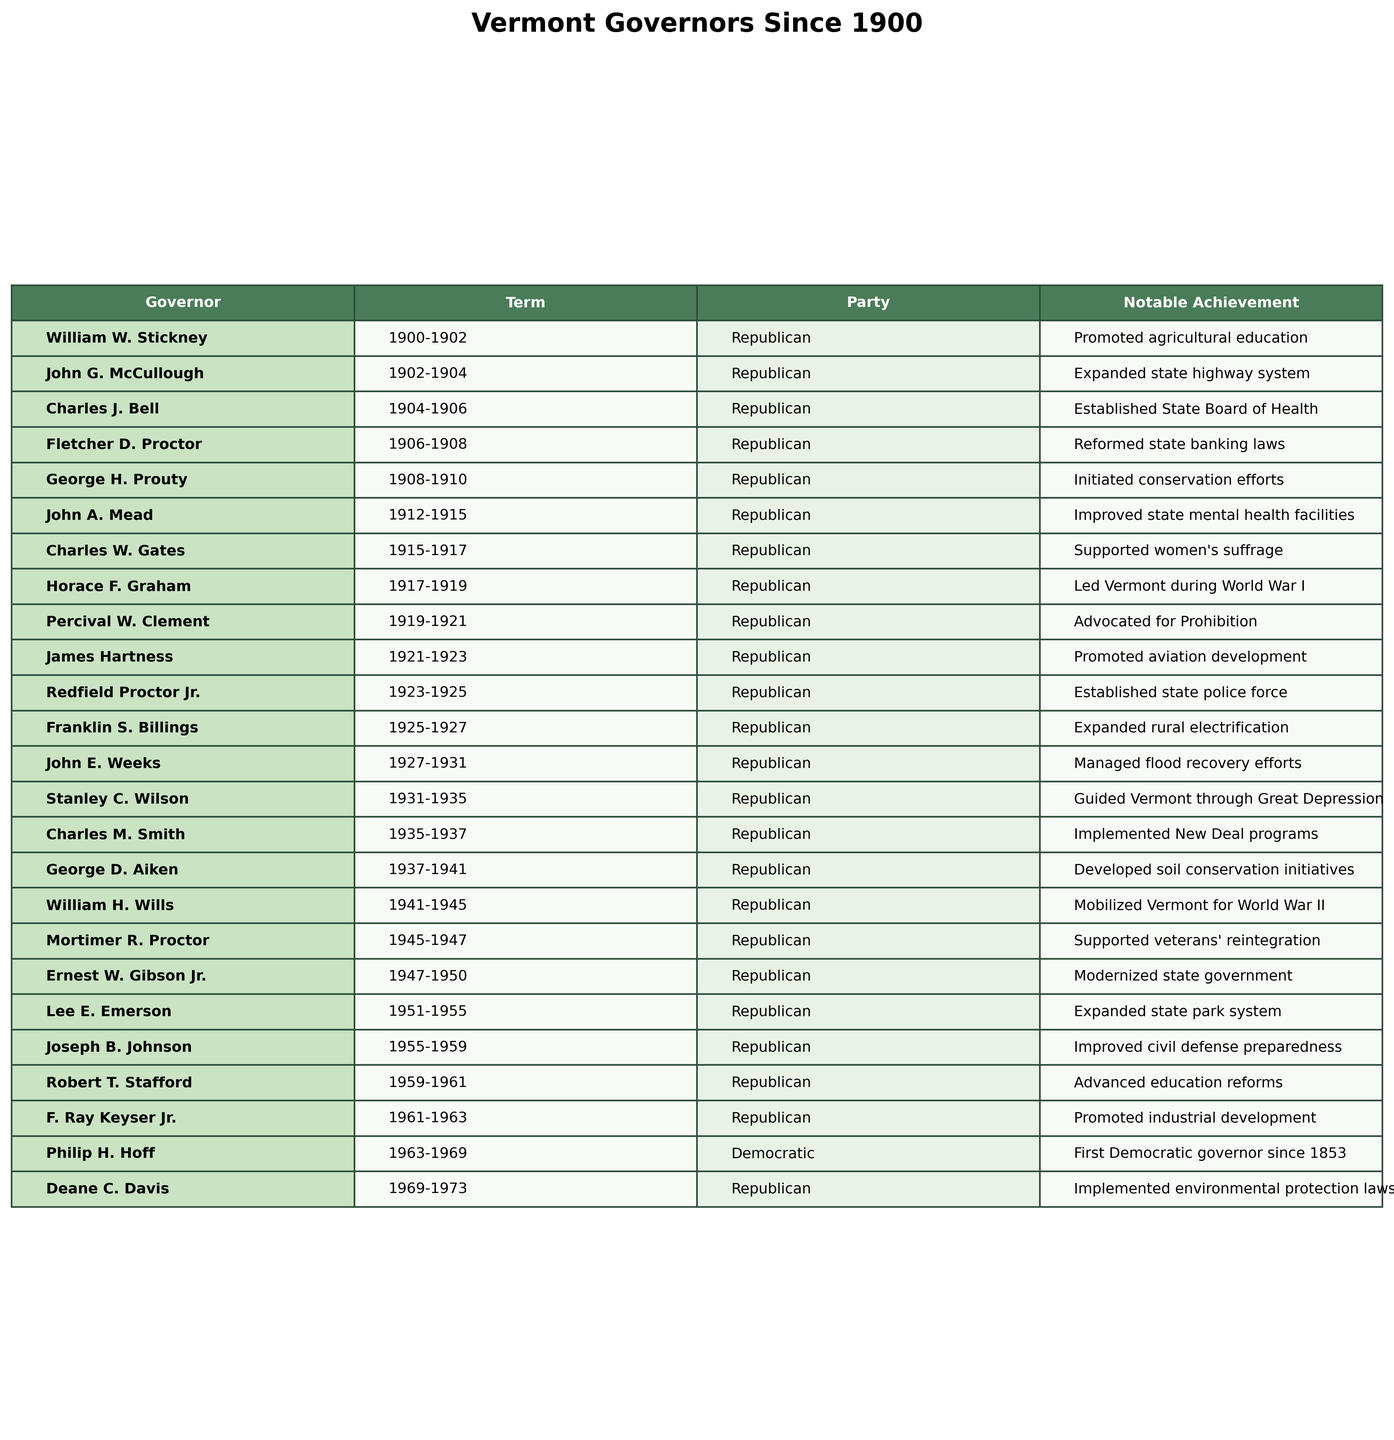What were the years of William W. Stickney's term? The table shows that William W. Stickney served as governor from 1900 to 1902.
Answer: 1900-1902 Which governor had the longest term in office? By checking the "Start Year" and "End Year" columns, we see that Stanley C. Wilson served from 1931 to 1935, totaling 4 years, which is the longest duration among the listed governors.
Answer: Stanley C. Wilson How many governors served from the Republican Party? All governors listed from 1900 to 1973 except for Philip H. Hoff (1963-1969) were from the Republican Party. Counting these, there are 22 Republican governors.
Answer: 22 Did any governor serve during World War II? William H. Wills served from 1941 to 1945, which overlaps with the World War II timeline. Hence, the answer is yes.
Answer: Yes What notable achievement is attributed to George D. Aiken? Referring to the table, George D. Aiken's notable achievement was developing soil conservation initiatives.
Answer: Developed soil conservation initiatives Calculate the total number of years served by all governors listed in the table. Adding together all the years served (2 + 2 + 2 + 2 + 2 + 3 + 2 + 2 + 2 + 2 + 2 + 4 + 4 + 4 + 4 + 2 + 3 + 2 + 2 + 6 + 4 = 60), the total is 60 years.
Answer: 60 Was there any governor who directly contributed to women's suffrage? The table lists Charles W. Gates, who was noted for supporting women's suffrage. Hence, the answer is yes.
Answer: Yes Identify the governor directly associated with the establishment of the state police force. According to the table, Redfield Proctor Jr. is the governor who established the state police force between 1923 and 1925.
Answer: Redfield Proctor Jr Which party did Philip H. Hoff belong to? The table explicitly categorizes Philip H. Hoff under the Democratic Party, signifying his political affiliation.
Answer: Democratic Party What is the notable achievement of Ernest W. Gibson Jr.? The table states that Ernest W. Gibson Jr. modernized state government, which is his notable achievement.
Answer: Modernized state government Which two governors served consecutive terms in the table? By examining the terms, Stanley C. Wilson (1931-1935) and Charles M. Smith (1935-1937) served back-to-back, as the next governor followed right after the previous one's term ended.
Answer: Stanley C. Wilson and Charles M. Smith 